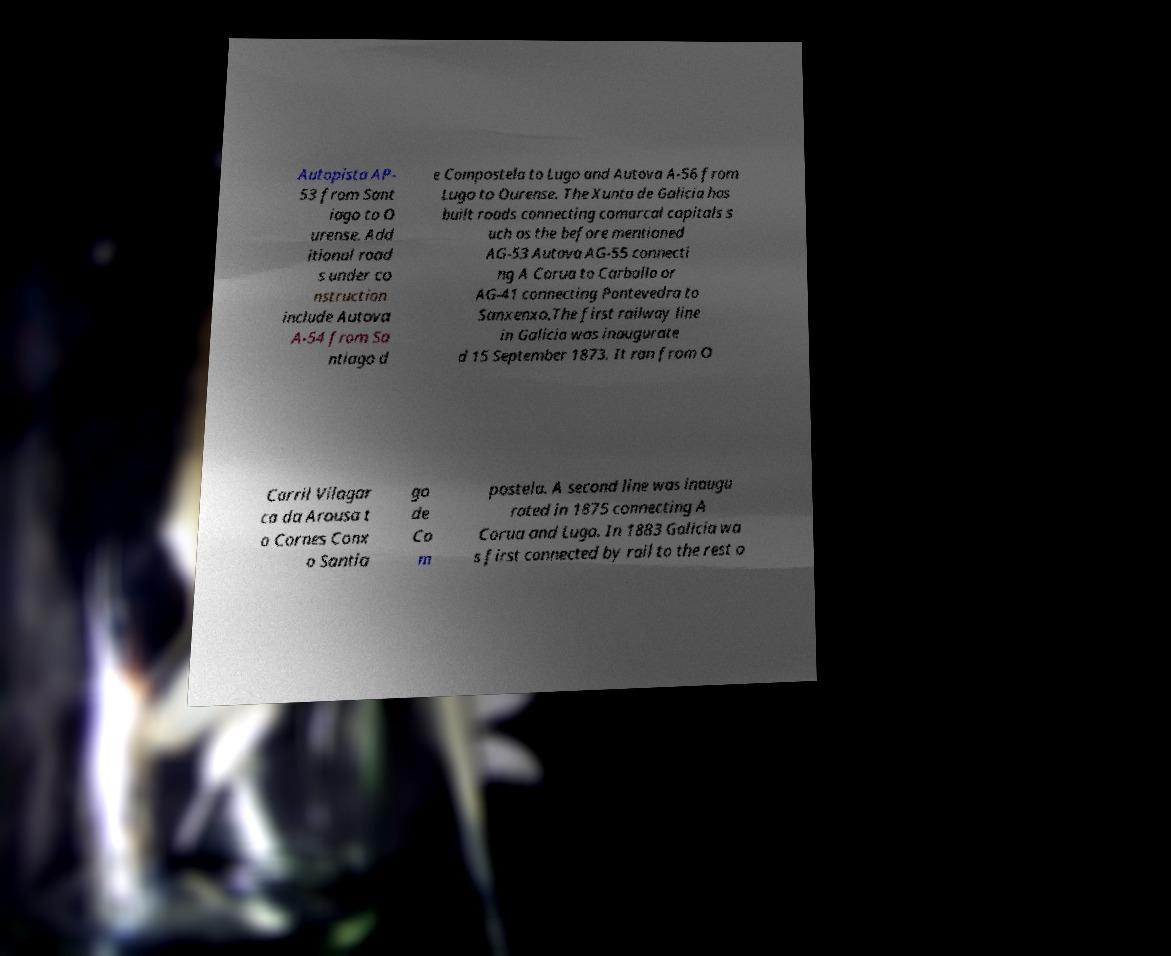Please read and relay the text visible in this image. What does it say? Autopista AP- 53 from Sant iago to O urense. Add itional road s under co nstruction include Autova A-54 from Sa ntiago d e Compostela to Lugo and Autova A-56 from Lugo to Ourense. The Xunta de Galicia has built roads connecting comarcal capitals s uch as the before mentioned AG-53 Autova AG-55 connecti ng A Corua to Carballo or AG-41 connecting Pontevedra to Sanxenxo.The first railway line in Galicia was inaugurate d 15 September 1873. It ran from O Carril Vilagar ca da Arousa t o Cornes Conx o Santia go de Co m postela. A second line was inaugu rated in 1875 connecting A Corua and Lugo. In 1883 Galicia wa s first connected by rail to the rest o 